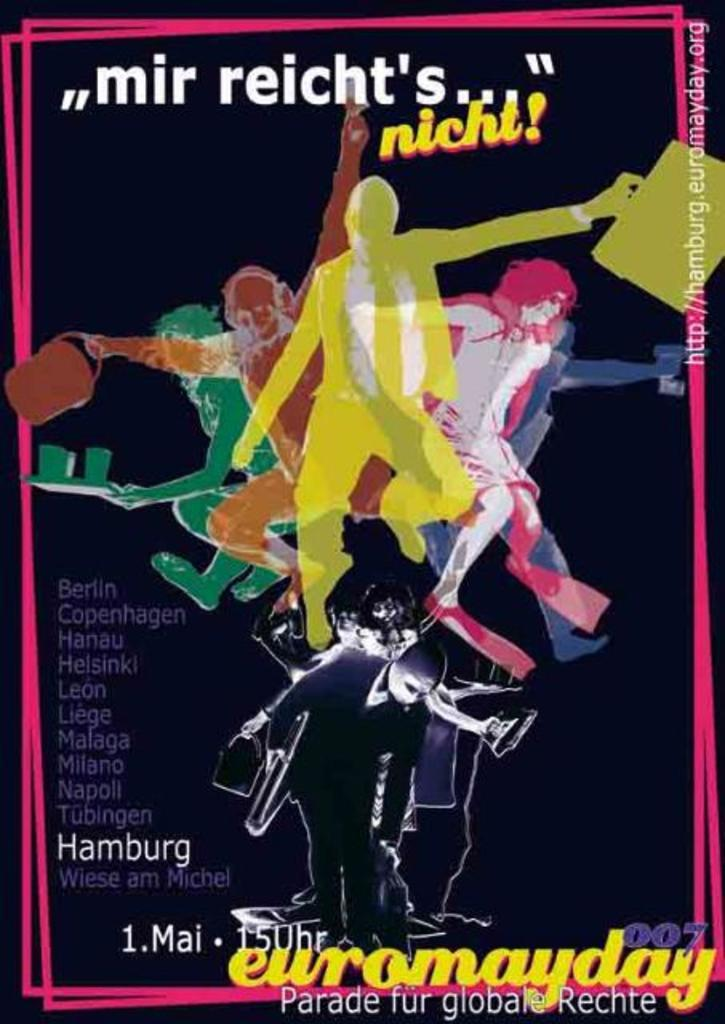<image>
Give a short and clear explanation of the subsequent image. a movie poster with the city of Hamburg on it 